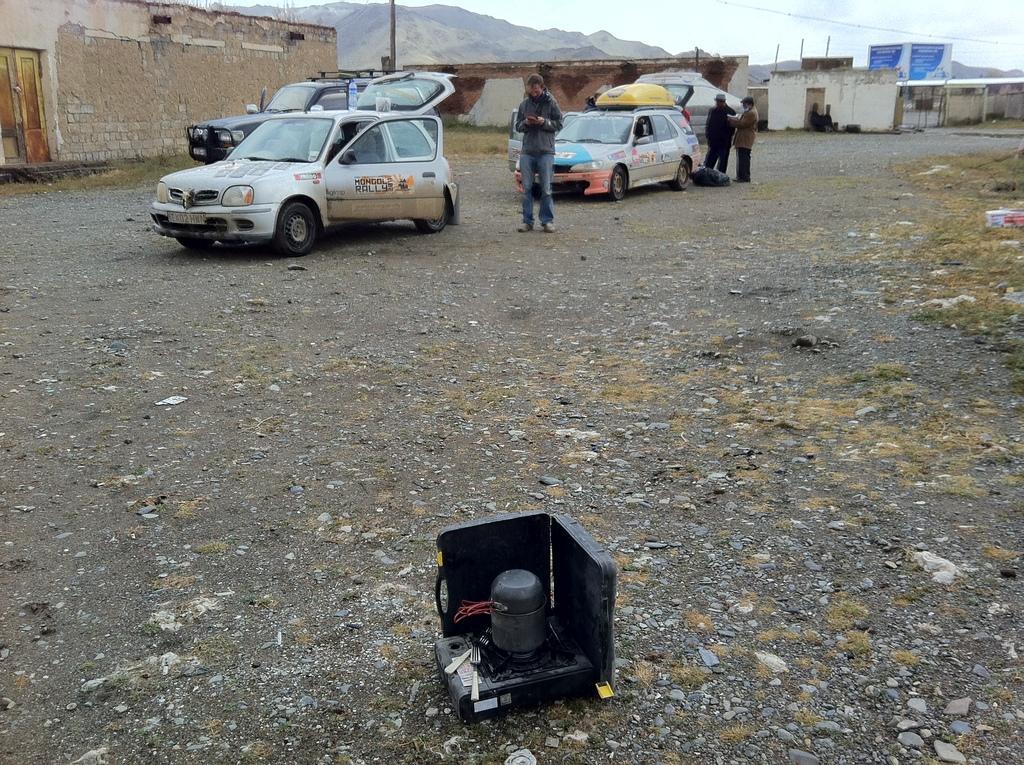Can you describe this image briefly? In this image I can see there are three persons standing in front of vehicles, vehicles kept on floor, and there is a object visible at the bottom and there is the wall, houses, hill and the sky visible at the top. 